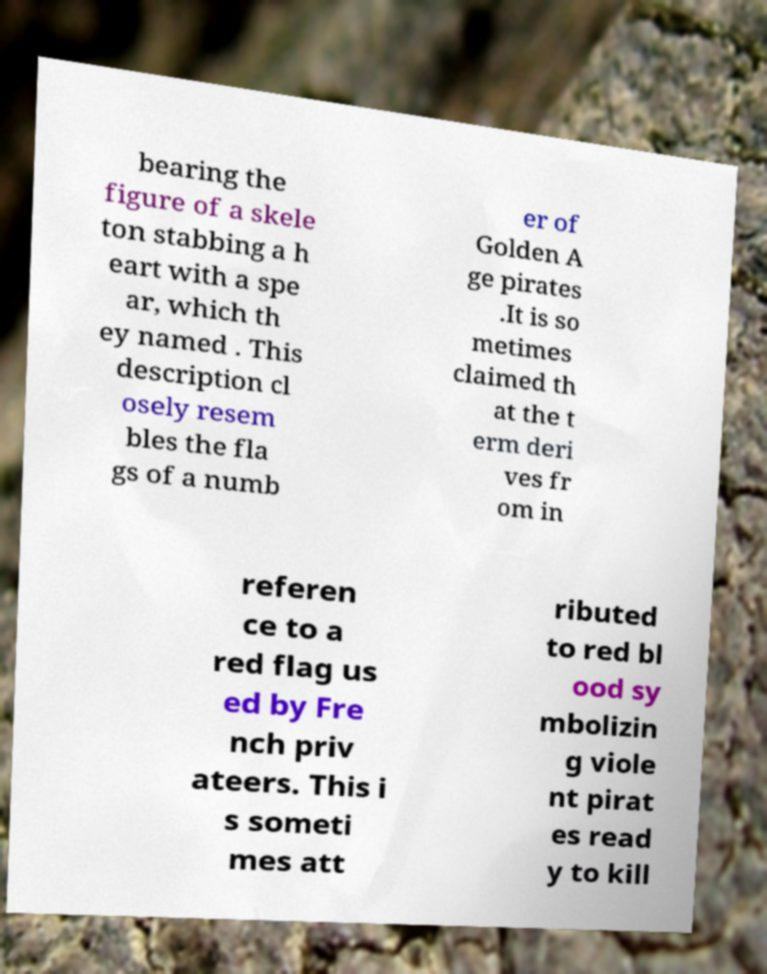What messages or text are displayed in this image? I need them in a readable, typed format. bearing the figure of a skele ton stabbing a h eart with a spe ar, which th ey named . This description cl osely resem bles the fla gs of a numb er of Golden A ge pirates .It is so metimes claimed th at the t erm deri ves fr om in referen ce to a red flag us ed by Fre nch priv ateers. This i s someti mes att ributed to red bl ood sy mbolizin g viole nt pirat es read y to kill 